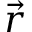Convert formula to latex. <formula><loc_0><loc_0><loc_500><loc_500>\vec { r }</formula> 